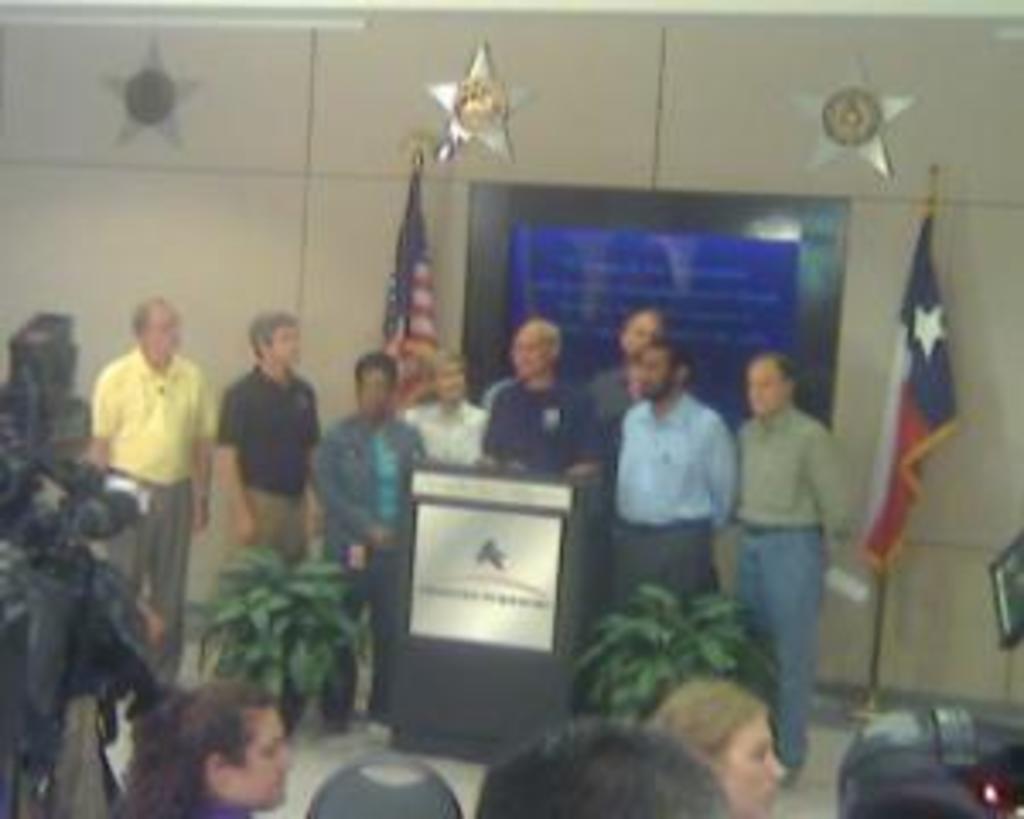Could you give a brief overview of what you see in this image? Here we can see a group of people. In-front of this person there is a podium. Beside this podium there are plants. Backside of these people there are flags and board. Stars are on the wall. 